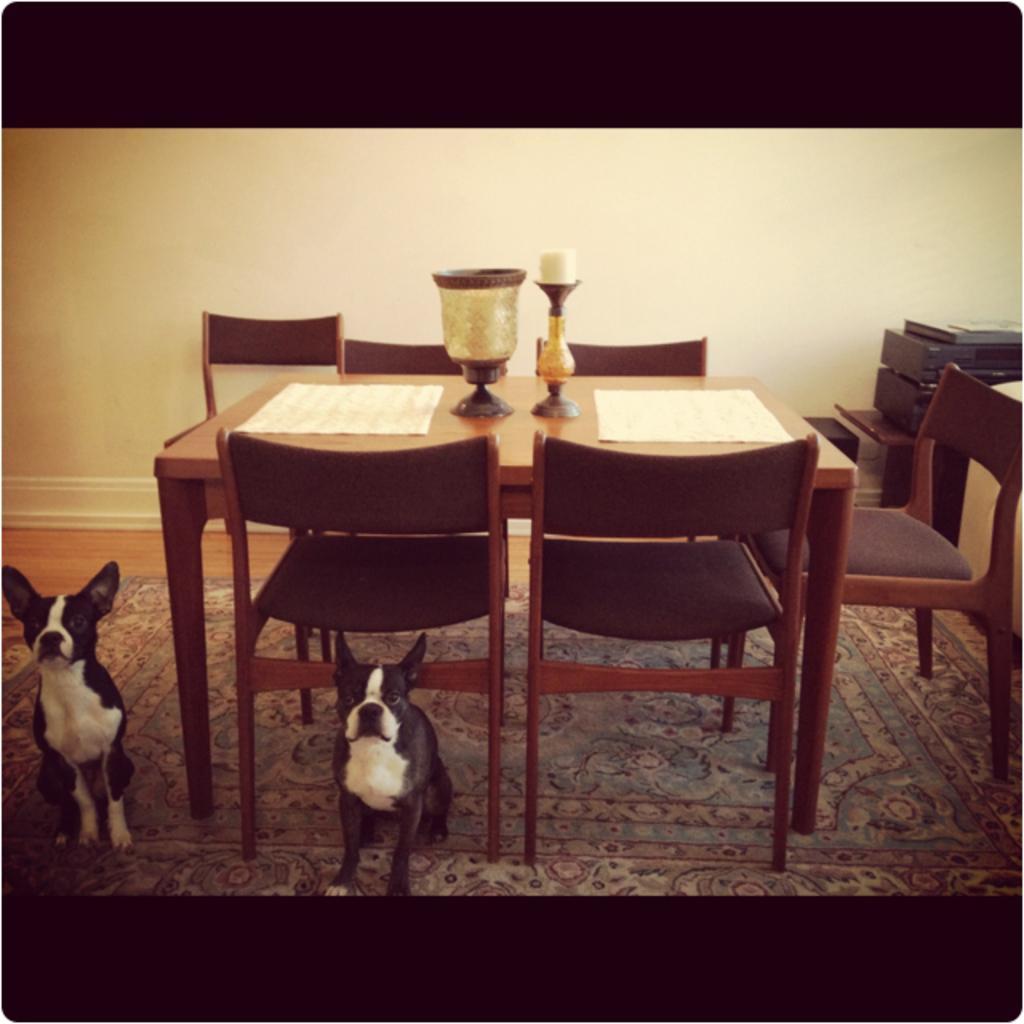Describe this image in one or two sentences. In this image, we can see a dining table with chairs. Top of the dining table, we can see mats, few objects, candle. At the bottom, there is a floor mat. Here two dogs are sitting on the mat. Right side of the image, we can see table, few objects. Background there is a wall. At the top and bottom of the image, we can see black color. 